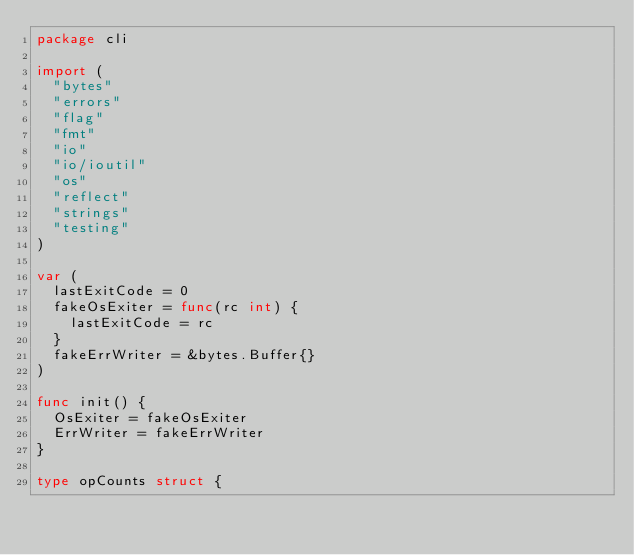Convert code to text. <code><loc_0><loc_0><loc_500><loc_500><_Go_>package cli

import (
	"bytes"
	"errors"
	"flag"
	"fmt"
	"io"
	"io/ioutil"
	"os"
	"reflect"
	"strings"
	"testing"
)

var (
	lastExitCode = 0
	fakeOsExiter = func(rc int) {
		lastExitCode = rc
	}
	fakeErrWriter = &bytes.Buffer{}
)

func init() {
	OsExiter = fakeOsExiter
	ErrWriter = fakeErrWriter
}

type opCounts struct {</code> 